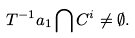Convert formula to latex. <formula><loc_0><loc_0><loc_500><loc_500>T ^ { - 1 } a _ { 1 } \bigcap C ^ { i } \neq \emptyset .</formula> 